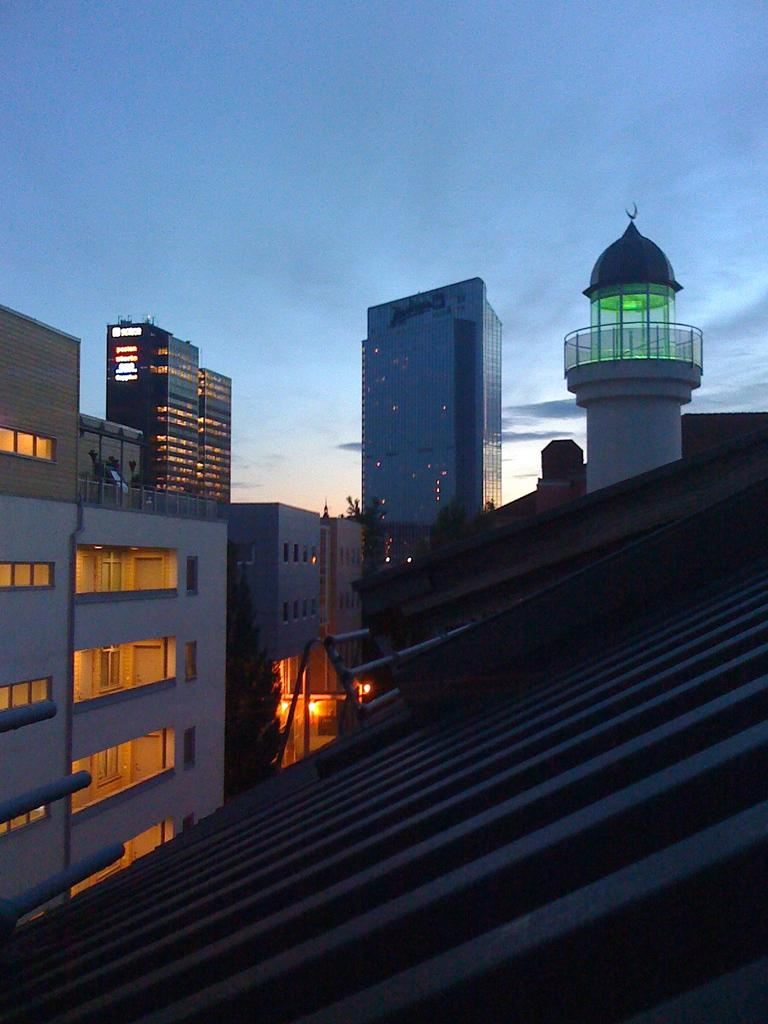What type of structures can be seen in the image? There are buildings in the image. Where is the viewpoint of the image located? The rooftop is visible in the image, suggesting that the viewpoint is from an elevated position. What can be seen illuminated in the image? There are lights in the image. What is visible in the background of the image? The sky is visible in the background of the image. Can you see any dolls on the airport runway in the image? There is no airport or runway present in the image, and therefore no dolls can be seen. 